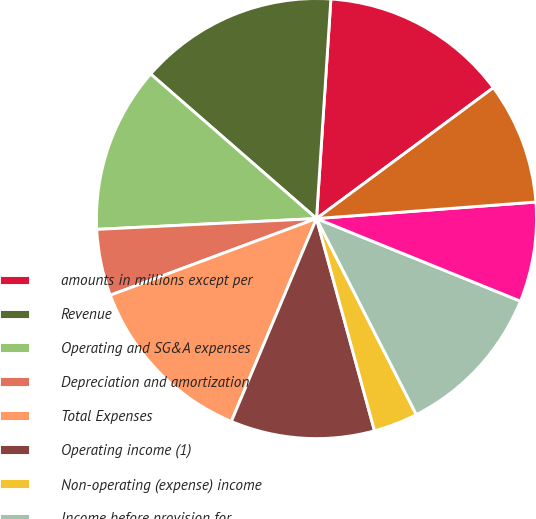Convert chart. <chart><loc_0><loc_0><loc_500><loc_500><pie_chart><fcel>amounts in millions except per<fcel>Revenue<fcel>Operating and SG&A expenses<fcel>Depreciation and amortization<fcel>Total Expenses<fcel>Operating income (1)<fcel>Non-operating (expense) income<fcel>Income before provision for<fcel>Provision for income taxes (3)<fcel>Net income (1)<nl><fcel>13.82%<fcel>14.63%<fcel>12.19%<fcel>4.88%<fcel>13.01%<fcel>10.57%<fcel>3.25%<fcel>11.38%<fcel>7.32%<fcel>8.94%<nl></chart> 